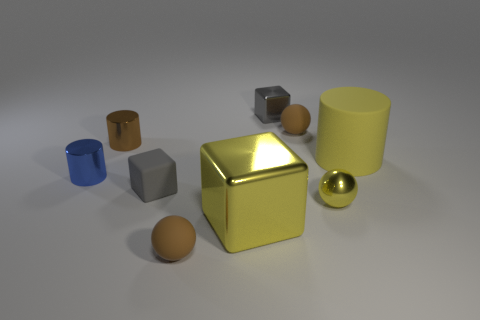What is the size of the brown object that is the same shape as the small blue shiny object?
Make the answer very short. Small. Is there a small metallic thing right of the brown matte sphere that is in front of the tiny gray cube that is in front of the yellow matte thing?
Keep it short and to the point. Yes. There is a ball that is in front of the big metal block; what is its material?
Offer a terse response. Rubber. What number of tiny objects are brown spheres or metallic objects?
Your answer should be very brief. 6. There is a brown matte ball that is in front of the metal sphere; is it the same size as the blue metallic cylinder?
Give a very brief answer. Yes. What number of other things are the same color as the metallic ball?
Offer a terse response. 2. What is the big yellow cylinder made of?
Make the answer very short. Rubber. There is a object that is in front of the blue shiny cylinder and behind the metallic ball; what material is it?
Your answer should be compact. Rubber. How many things are either tiny metal spheres that are in front of the tiny blue metallic cylinder or tiny brown balls?
Your response must be concise. 3. Does the large matte thing have the same color as the big metallic cube?
Give a very brief answer. Yes. 